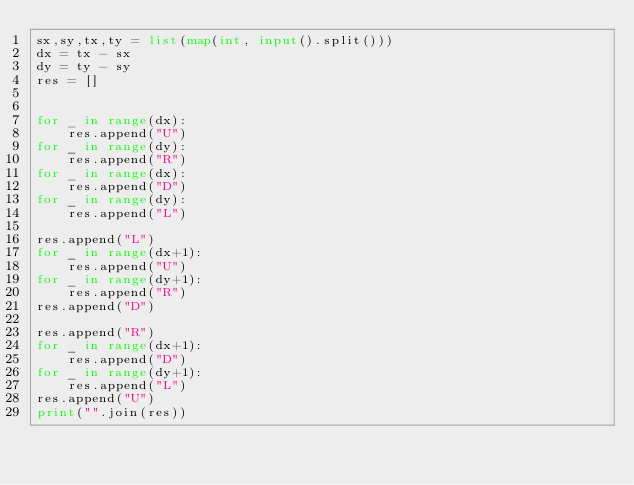Convert code to text. <code><loc_0><loc_0><loc_500><loc_500><_Python_>sx,sy,tx,ty = list(map(int, input().split()))
dx = tx - sx
dy = ty - sy
res = []


for _ in range(dx):
	res.append("U")
for _ in range(dy):
	res.append("R")
for _ in range(dx):
	res.append("D")
for _ in range(dy):
	res.append("L")

res.append("L")
for _ in range(dx+1):
	res.append("U")
for _ in range(dy+1):
	res.append("R")
res.append("D")

res.append("R")
for _ in range(dx+1):
	res.append("D")
for _ in range(dy+1):
	res.append("L")
res.append("U")
print("".join(res))</code> 